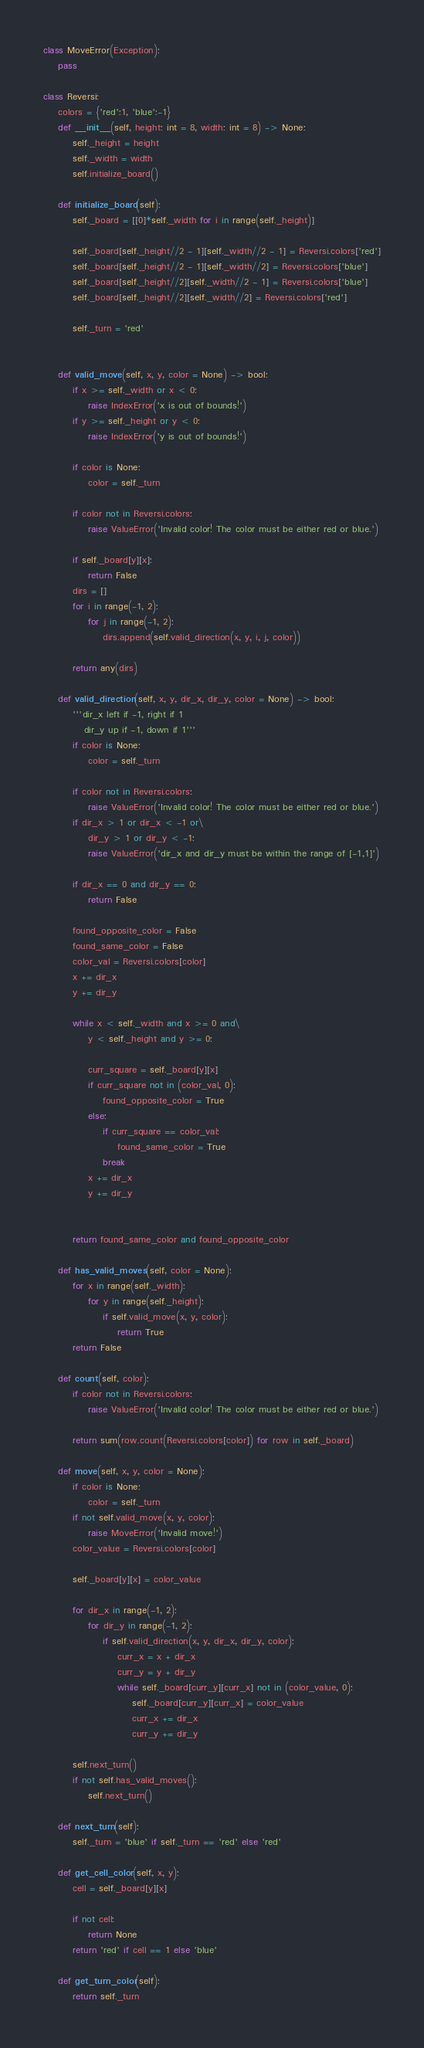Convert code to text. <code><loc_0><loc_0><loc_500><loc_500><_Python_>

class MoveError(Exception):
    pass

class Reversi:
    colors = {'red':1, 'blue':-1}
    def __init__(self, height: int = 8, width: int = 8) -> None:
        self._height = height
        self._width = width
        self.initialize_board()

    def initialize_board(self):
        self._board = [[0]*self._width for i in range(self._height)]

        self._board[self._height//2 - 1][self._width//2 - 1] = Reversi.colors['red']
        self._board[self._height//2 - 1][self._width//2] = Reversi.colors['blue']
        self._board[self._height//2][self._width//2 - 1] = Reversi.colors['blue']
        self._board[self._height//2][self._width//2] = Reversi.colors['red']

        self._turn = 'red'
        
    
    def valid_move(self, x, y, color = None) -> bool:
        if x >= self._width or x < 0:
            raise IndexError('x is out of bounds!')
        if y >= self._height or y < 0:
            raise IndexError('y is out of bounds!')

        if color is None:
            color = self._turn

        if color not in Reversi.colors:
            raise ValueError('Invalid color! The color must be either red or blue.')
        
        if self._board[y][x]:
            return False
        dirs = []
        for i in range(-1, 2):
            for j in range(-1, 2):
                dirs.append(self.valid_direction(x, y, i, j, color))
        
        return any(dirs)

    def valid_direction(self, x, y, dir_x, dir_y, color = None) -> bool:
        '''dir_x left if -1, right if 1
           dir_y up if -1, down if 1'''
        if color is None:
            color = self._turn

        if color not in Reversi.colors:
            raise ValueError('Invalid color! The color must be either red or blue.')
        if dir_x > 1 or dir_x < -1 or\
            dir_y > 1 or dir_y < -1:
            raise ValueError('dir_x and dir_y must be within the range of [-1,1]')
        
        if dir_x == 0 and dir_y == 0:
            return False

        found_opposite_color = False
        found_same_color = False
        color_val = Reversi.colors[color]
        x += dir_x
        y += dir_y

        while x < self._width and x >= 0 and\
            y < self._height and y >= 0:
            
            curr_square = self._board[y][x]
            if curr_square not in (color_val, 0):
                found_opposite_color = True
            else:
                if curr_square == color_val:
                    found_same_color = True
                break
            x += dir_x
            y += dir_y

        
        return found_same_color and found_opposite_color
        
    def has_valid_moves(self, color = None):
        for x in range(self._width):
            for y in range(self._height):
                if self.valid_move(x, y, color):
                    return True
        return False

    def count(self, color):
        if color not in Reversi.colors:
            raise ValueError('Invalid color! The color must be either red or blue.')
        
        return sum(row.count(Reversi.colors[color]) for row in self._board)

    def move(self, x, y, color = None):
        if color is None:
            color = self._turn
        if not self.valid_move(x, y, color):
            raise MoveError('Invalid move!')
        color_value = Reversi.colors[color]
        
        self._board[y][x] = color_value

        for dir_x in range(-1, 2):
            for dir_y in range(-1, 2):
                if self.valid_direction(x, y, dir_x, dir_y, color):
                    curr_x = x + dir_x
                    curr_y = y + dir_y
                    while self._board[curr_y][curr_x] not in (color_value, 0):
                        self._board[curr_y][curr_x] = color_value
                        curr_x += dir_x
                        curr_y += dir_y

        self.next_turn()
        if not self.has_valid_moves():
            self.next_turn()

    def next_turn(self):
        self._turn = 'blue' if self._turn == 'red' else 'red'

    def get_cell_color(self, x, y):
        cell = self._board[y][x]

        if not cell:
            return None
        return 'red' if cell == 1 else 'blue'

    def get_turn_color(self):
        return self._turn
</code> 